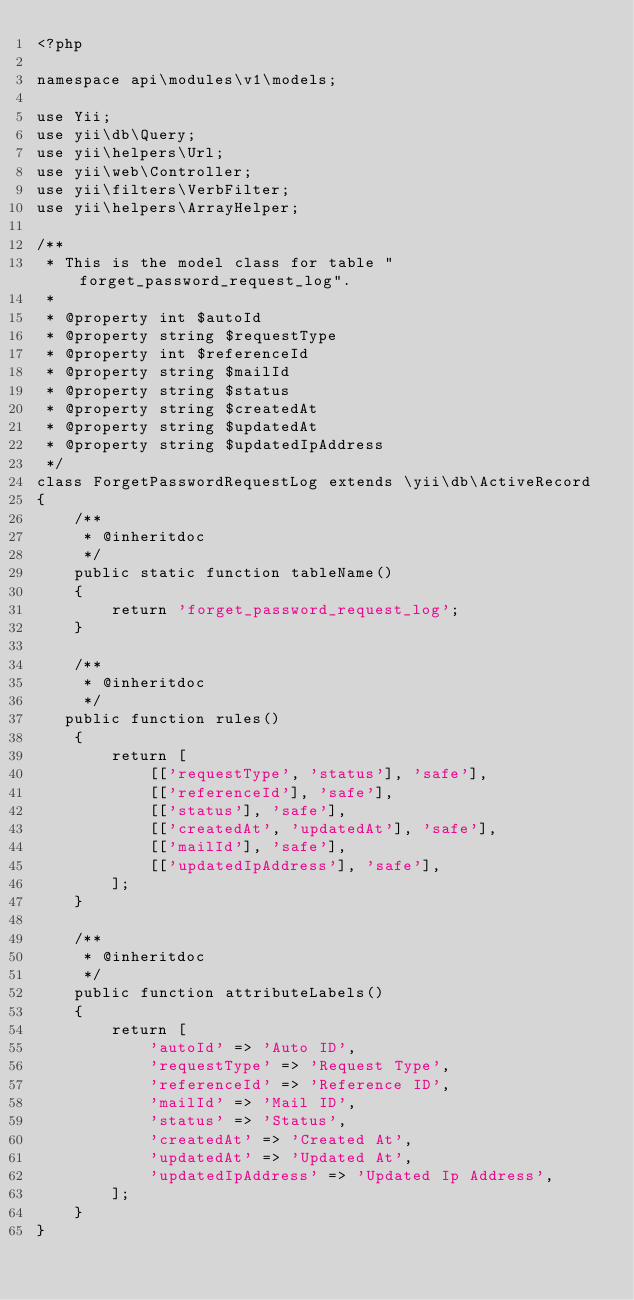<code> <loc_0><loc_0><loc_500><loc_500><_PHP_><?php

namespace api\modules\v1\models;

use Yii;
use yii\db\Query;
use yii\helpers\Url;
use yii\web\Controller;
use yii\filters\VerbFilter;
use yii\helpers\ArrayHelper;

/**
 * This is the model class for table "forget_password_request_log".
 *
 * @property int $autoId
 * @property string $requestType
 * @property int $referenceId
 * @property string $mailId
 * @property string $status
 * @property string $createdAt
 * @property string $updatedAt
 * @property string $updatedIpAddress
 */
class ForgetPasswordRequestLog extends \yii\db\ActiveRecord
{
    /**
     * @inheritdoc
     */
    public static function tableName()
    {
        return 'forget_password_request_log';
    }

    /**
     * @inheritdoc
     */
   public function rules()
    {
        return [
            [['requestType', 'status'], 'safe'],
            [['referenceId'], 'safe'],
            [['status'], 'safe'],
            [['createdAt', 'updatedAt'], 'safe'],
            [['mailId'], 'safe'],
            [['updatedIpAddress'], 'safe'],
        ];
    }

    /**
     * @inheritdoc
     */
    public function attributeLabels()
    {
        return [
            'autoId' => 'Auto ID',
            'requestType' => 'Request Type',
            'referenceId' => 'Reference ID',
            'mailId' => 'Mail ID',
            'status' => 'Status',
            'createdAt' => 'Created At',
            'updatedAt' => 'Updated At',
            'updatedIpAddress' => 'Updated Ip Address',
        ];
    }
}
</code> 